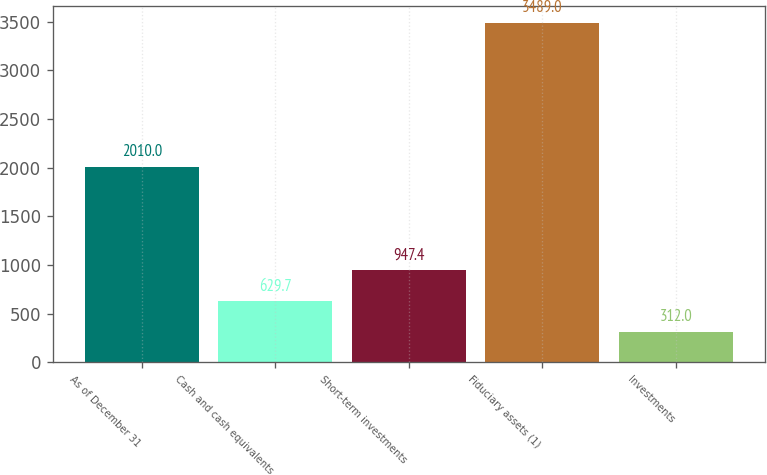Convert chart to OTSL. <chart><loc_0><loc_0><loc_500><loc_500><bar_chart><fcel>As of December 31<fcel>Cash and cash equivalents<fcel>Short-term investments<fcel>Fiduciary assets (1)<fcel>Investments<nl><fcel>2010<fcel>629.7<fcel>947.4<fcel>3489<fcel>312<nl></chart> 